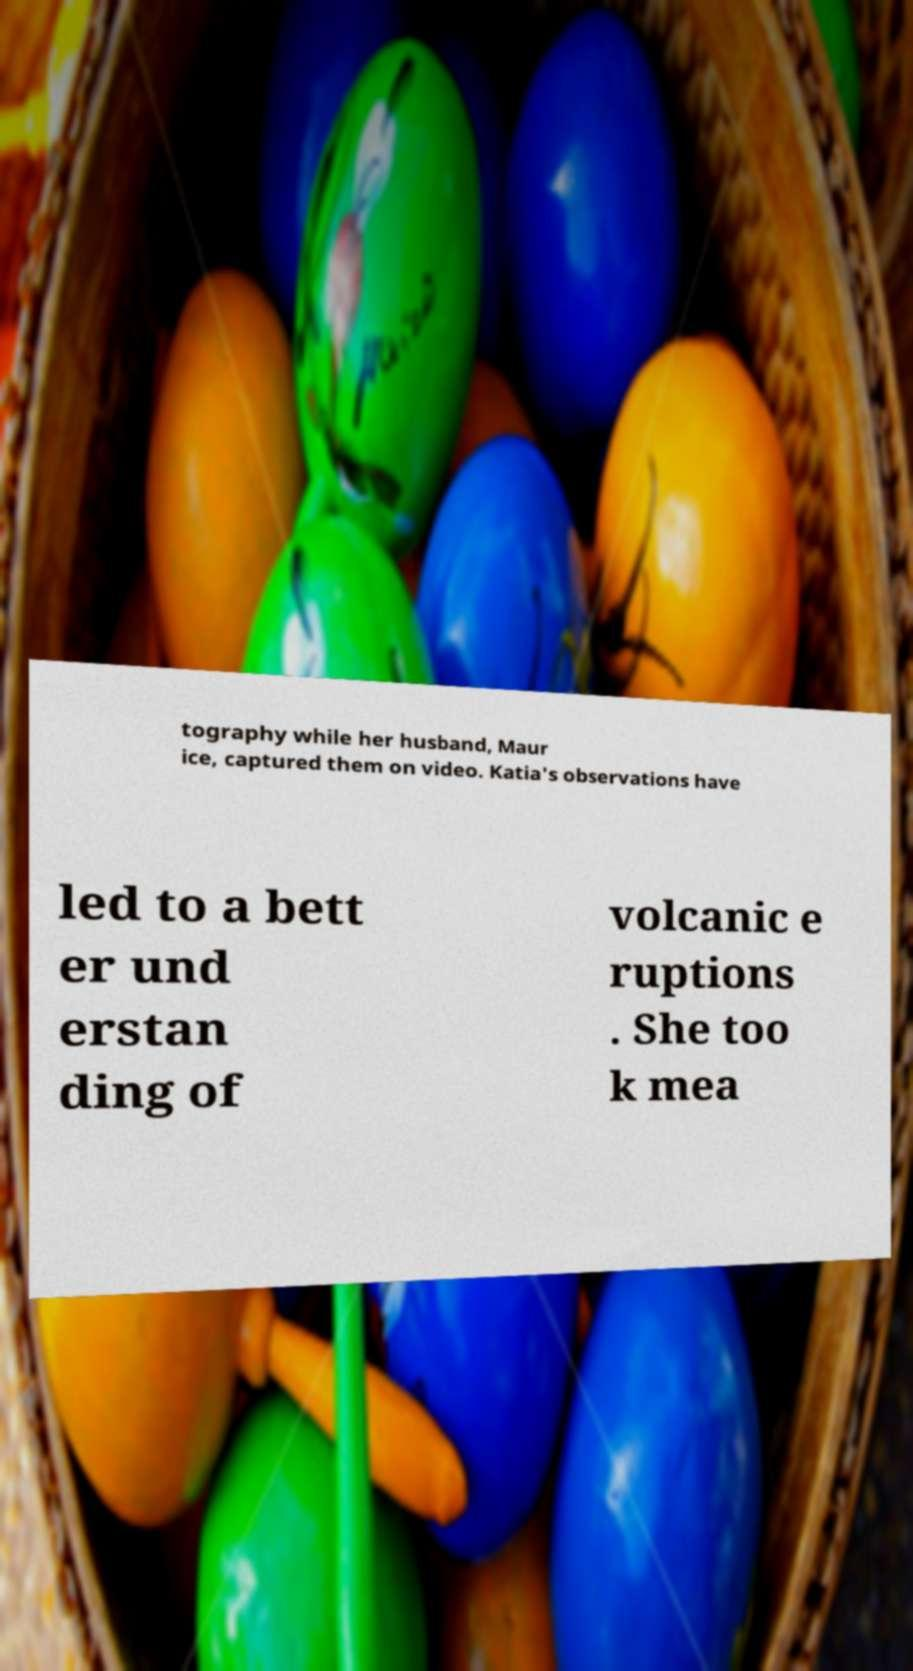What messages or text are displayed in this image? I need them in a readable, typed format. tography while her husband, Maur ice, captured them on video. Katia's observations have led to a bett er und erstan ding of volcanic e ruptions . She too k mea 